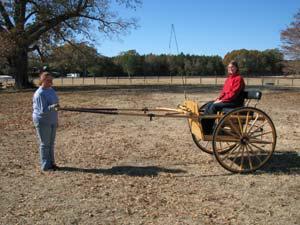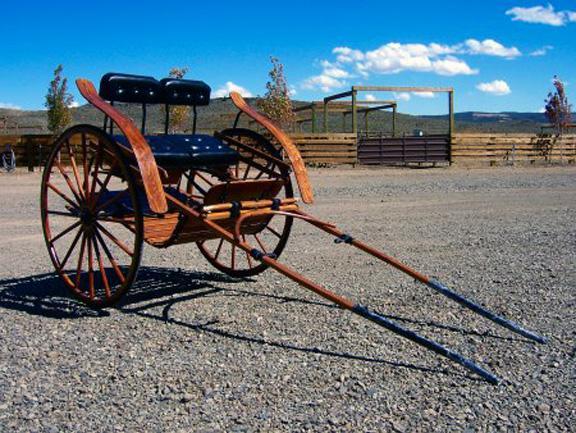The first image is the image on the left, the second image is the image on the right. For the images shown, is this caption "An image features a four-wheeled cart with distinctly smaller wheels at the front." true? Answer yes or no. No. The first image is the image on the left, the second image is the image on the right. Considering the images on both sides, is "The front leads of the carriage are resting on the ground in one of the images." valid? Answer yes or no. Yes. 